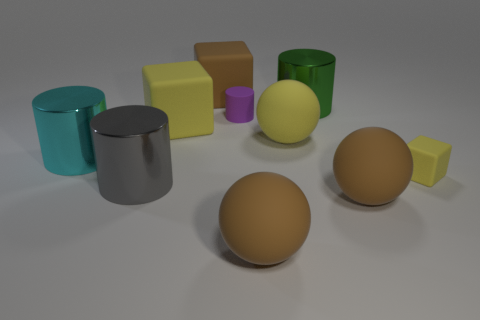The large yellow object that is on the right side of the large cube behind the big yellow rubber block that is in front of the tiny purple thing is what shape?
Your answer should be very brief. Sphere. There is a big gray shiny thing; what shape is it?
Your response must be concise. Cylinder. What shape is the green shiny object that is the same size as the brown cube?
Your answer should be very brief. Cylinder. How many other objects are the same color as the small cube?
Ensure brevity in your answer.  2. Is the shape of the cyan object that is behind the large gray object the same as the big brown thing that is on the left side of the purple matte cylinder?
Provide a short and direct response. No. How many things are small things behind the small cube or rubber spheres that are in front of the tiny block?
Your answer should be compact. 3. How many other objects are the same material as the big green cylinder?
Ensure brevity in your answer.  2. Do the brown cube that is on the left side of the big green object and the purple thing have the same material?
Your answer should be compact. Yes. Are there more large cyan shiny cylinders that are behind the cyan thing than brown matte blocks that are in front of the small cylinder?
Provide a short and direct response. No. How many objects are either large metal things on the right side of the cyan shiny cylinder or matte blocks?
Provide a succinct answer. 5. 